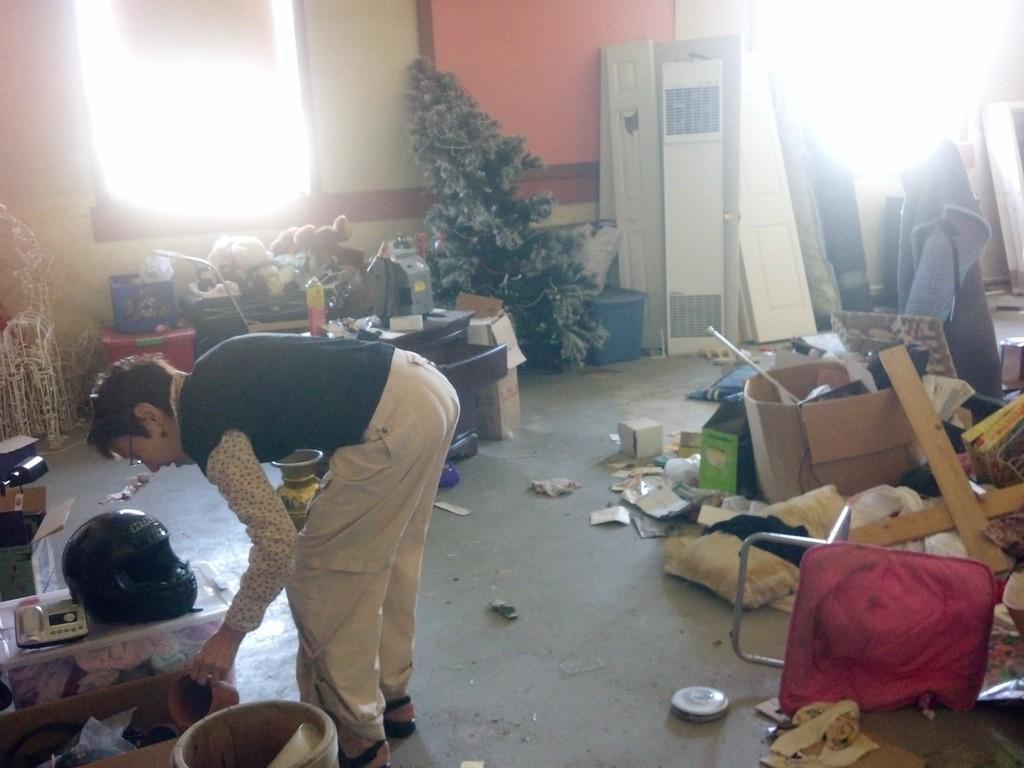Could you give a brief overview of what you see in this image? In this picture there are boxes, broken doors, chairs, and other items, which are scattered in the image and there is a man on the left side of the image, there is a helmet on the table on the left side of the image, there are windows in the image. 